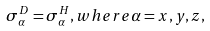Convert formula to latex. <formula><loc_0><loc_0><loc_500><loc_500>\sigma ^ { D } _ { \alpha } = \sigma ^ { H } _ { \alpha } , w h e r e \alpha = x , y , z ,</formula> 